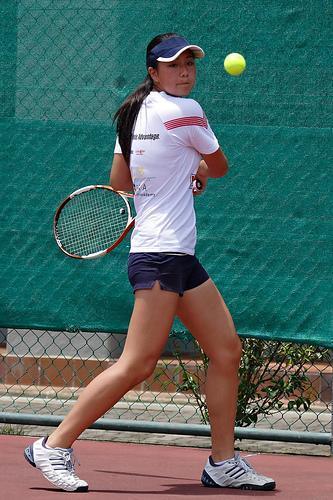How many people are playing football?
Give a very brief answer. 0. 